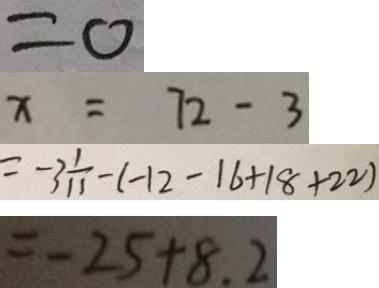Convert formula to latex. <formula><loc_0><loc_0><loc_500><loc_500>= 0 
 x = 7 2 - 3 
 = - 3 \frac { 1 } { 1 1 } - ( - 1 2 - 1 6 + 1 8 + 2 2 ) 
 = - 2 5 + 8 . 2</formula> 